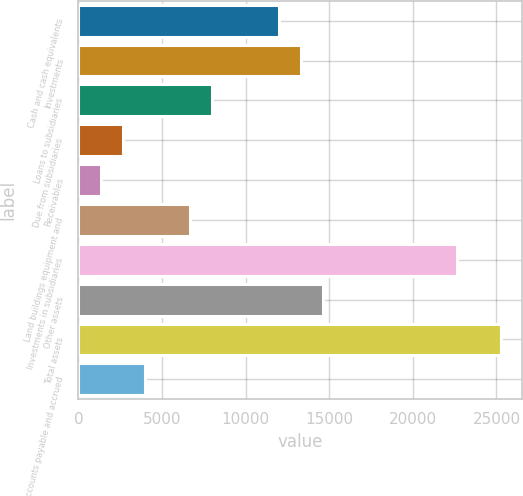<chart> <loc_0><loc_0><loc_500><loc_500><bar_chart><fcel>Cash and cash equivalents<fcel>Investments<fcel>Loans to subsidiaries<fcel>Due from subsidiaries<fcel>Receivables<fcel>Land buildings equipment and<fcel>Investments in subsidiaries<fcel>Other assets<fcel>Total assets<fcel>Accounts payable and accrued<nl><fcel>11972.1<fcel>13302<fcel>7982.4<fcel>2662.8<fcel>1332.9<fcel>6652.5<fcel>22611.3<fcel>14631.9<fcel>25271.1<fcel>3992.7<nl></chart> 